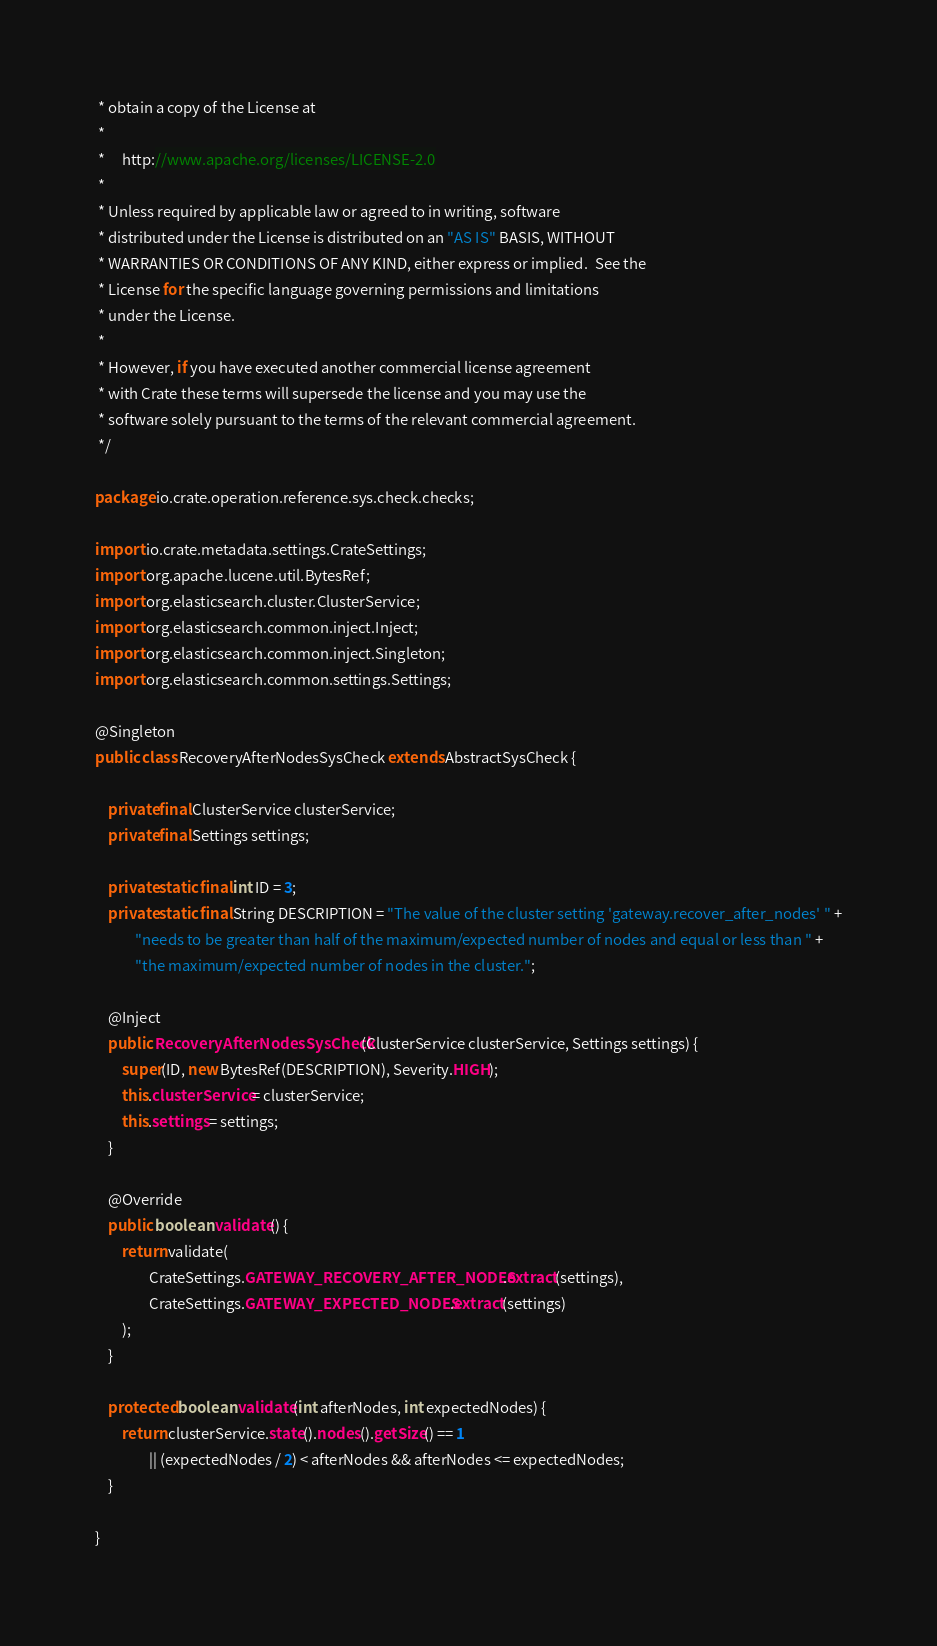Convert code to text. <code><loc_0><loc_0><loc_500><loc_500><_Java_> * obtain a copy of the License at
 *
 *     http://www.apache.org/licenses/LICENSE-2.0
 *
 * Unless required by applicable law or agreed to in writing, software
 * distributed under the License is distributed on an "AS IS" BASIS, WITHOUT
 * WARRANTIES OR CONDITIONS OF ANY KIND, either express or implied.  See the
 * License for the specific language governing permissions and limitations
 * under the License.
 *
 * However, if you have executed another commercial license agreement
 * with Crate these terms will supersede the license and you may use the
 * software solely pursuant to the terms of the relevant commercial agreement.
 */

package io.crate.operation.reference.sys.check.checks;

import io.crate.metadata.settings.CrateSettings;
import org.apache.lucene.util.BytesRef;
import org.elasticsearch.cluster.ClusterService;
import org.elasticsearch.common.inject.Inject;
import org.elasticsearch.common.inject.Singleton;
import org.elasticsearch.common.settings.Settings;

@Singleton
public class RecoveryAfterNodesSysCheck extends AbstractSysCheck {

    private final ClusterService clusterService;
    private final Settings settings;

    private static final int ID = 3;
    private static final String DESCRIPTION = "The value of the cluster setting 'gateway.recover_after_nodes' " +
            "needs to be greater than half of the maximum/expected number of nodes and equal or less than " +
            "the maximum/expected number of nodes in the cluster.";

    @Inject
    public RecoveryAfterNodesSysCheck(ClusterService clusterService, Settings settings) {
        super(ID, new BytesRef(DESCRIPTION), Severity.HIGH);
        this.clusterService = clusterService;
        this.settings = settings;
    }

    @Override
    public boolean validate() {
        return validate(
                CrateSettings.GATEWAY_RECOVERY_AFTER_NODES.extract(settings),
                CrateSettings.GATEWAY_EXPECTED_NODES.extract(settings)
        );
    }

    protected boolean validate(int afterNodes, int expectedNodes) {
        return clusterService.state().nodes().getSize() == 1
                || (expectedNodes / 2) < afterNodes && afterNodes <= expectedNodes;
    }

}
</code> 